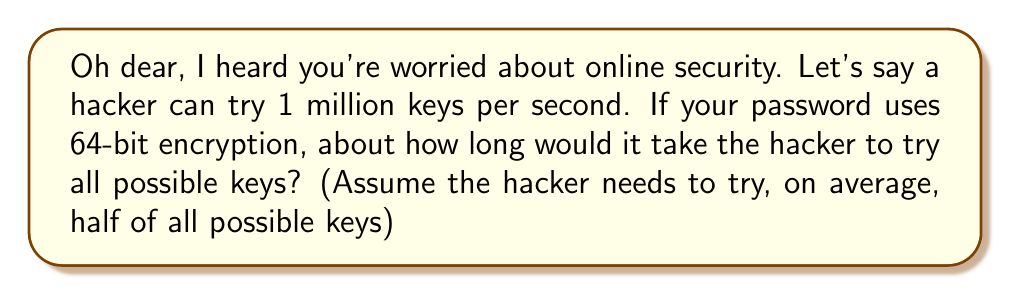Help me with this question. Let's approach this step-by-step, my dear:

1) First, we need to calculate the total number of possible keys for 64-bit encryption:
   $$ \text{Total keys} = 2^{64} $$

2) Now, on average, the hacker would need to try half of these:
   $$ \text{Keys to try} = \frac{2^{64}}{2} = 2^{63} $$

3) We're told the hacker can try 1 million keys per second. Let's express this mathematically:
   $$ \text{Keys per second} = 10^6 $$

4) To find the time in seconds, we divide the number of keys to try by the keys per second:
   $$ \text{Time (seconds)} = \frac{2^{63}}{10^6} $$

5) Let's calculate this:
   $$ \frac{2^{63}}{10^6} = \frac{9,223,372,036,854,775,808}{1,000,000} = 9,223,372,036,855 \text{ seconds} $$

6) To make this more understandable, let's convert to years:
   $$ \frac{9,223,372,036,855}{60 \times 60 \times 24 \times 365.25} \approx 292.5 \text{ years} $$

Don't worry, dear. This shows that 64-bit encryption is quite strong and would take a very long time to crack!
Answer: 292.5 years 